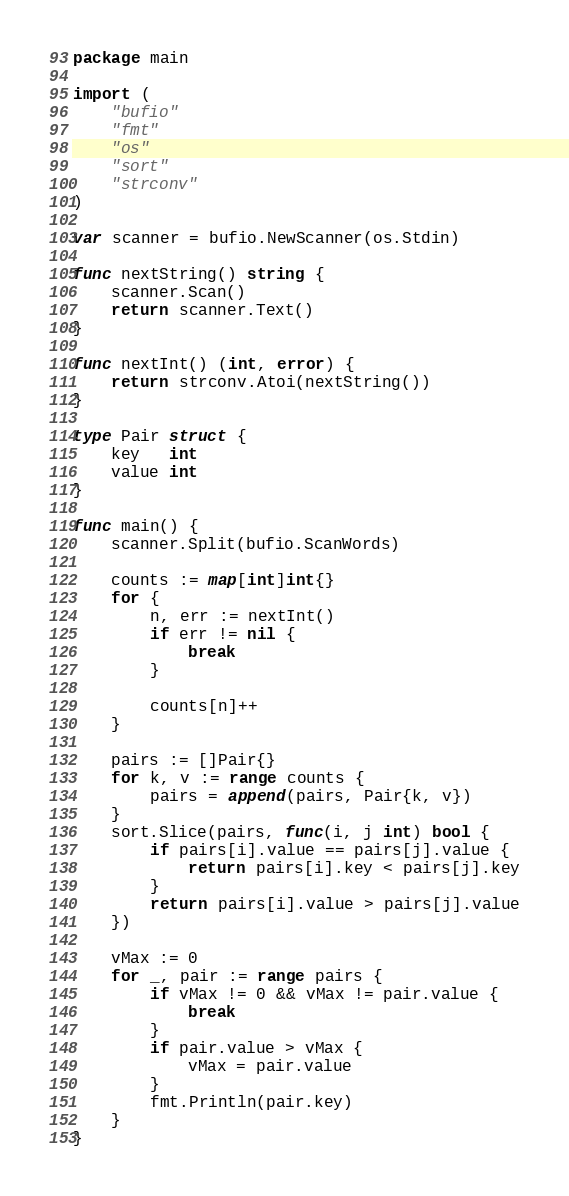Convert code to text. <code><loc_0><loc_0><loc_500><loc_500><_Go_>package main

import (
	"bufio"
	"fmt"
	"os"
	"sort"
	"strconv"
)

var scanner = bufio.NewScanner(os.Stdin)

func nextString() string {
	scanner.Scan()
	return scanner.Text()
}

func nextInt() (int, error) {
	return strconv.Atoi(nextString())
}

type Pair struct {
	key   int
	value int
}

func main() {
	scanner.Split(bufio.ScanWords)

	counts := map[int]int{}
	for {
		n, err := nextInt()
		if err != nil {
			break
		}

		counts[n]++
	}

	pairs := []Pair{}
	for k, v := range counts {
		pairs = append(pairs, Pair{k, v})
	}
	sort.Slice(pairs, func(i, j int) bool {
		if pairs[i].value == pairs[j].value {
			return pairs[i].key < pairs[j].key
		}
		return pairs[i].value > pairs[j].value
	})

	vMax := 0
	for _, pair := range pairs {
		if vMax != 0 && vMax != pair.value {
			break
		}
		if pair.value > vMax {
			vMax = pair.value
		}
		fmt.Println(pair.key)
	}
}

</code> 